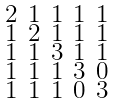Convert formula to latex. <formula><loc_0><loc_0><loc_500><loc_500>\begin{smallmatrix} 2 & 1 & 1 & 1 & 1 \\ 1 & 2 & 1 & 1 & 1 \\ 1 & 1 & 3 & 1 & 1 \\ 1 & 1 & 1 & 3 & 0 \\ 1 & 1 & 1 & 0 & 3 \end{smallmatrix}</formula> 